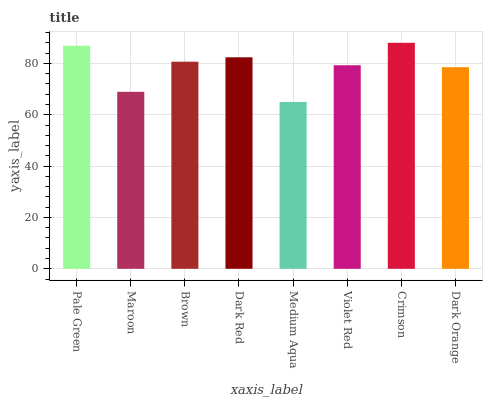Is Medium Aqua the minimum?
Answer yes or no. Yes. Is Crimson the maximum?
Answer yes or no. Yes. Is Maroon the minimum?
Answer yes or no. No. Is Maroon the maximum?
Answer yes or no. No. Is Pale Green greater than Maroon?
Answer yes or no. Yes. Is Maroon less than Pale Green?
Answer yes or no. Yes. Is Maroon greater than Pale Green?
Answer yes or no. No. Is Pale Green less than Maroon?
Answer yes or no. No. Is Brown the high median?
Answer yes or no. Yes. Is Violet Red the low median?
Answer yes or no. Yes. Is Dark Red the high median?
Answer yes or no. No. Is Medium Aqua the low median?
Answer yes or no. No. 